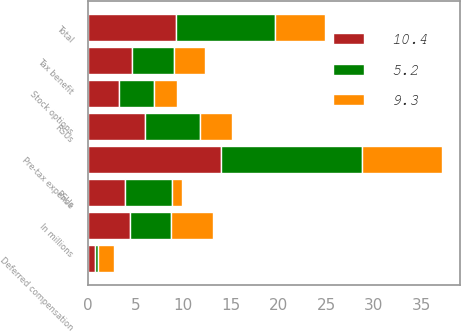Convert chart. <chart><loc_0><loc_0><loc_500><loc_500><stacked_bar_chart><ecel><fcel>In millions<fcel>Stock options<fcel>RSUs<fcel>PSUs<fcel>Deferred compensation<fcel>Pre-tax expense<fcel>Tax benefit<fcel>Total<nl><fcel>5.2<fcel>4.4<fcel>3.7<fcel>5.8<fcel>5<fcel>0.3<fcel>14.8<fcel>4.4<fcel>10.4<nl><fcel>10.4<fcel>4.4<fcel>3.3<fcel>6<fcel>3.9<fcel>0.8<fcel>14<fcel>4.7<fcel>9.3<nl><fcel>9.3<fcel>4.4<fcel>2.4<fcel>3.3<fcel>1<fcel>1.7<fcel>8.4<fcel>3.2<fcel>5.2<nl></chart> 